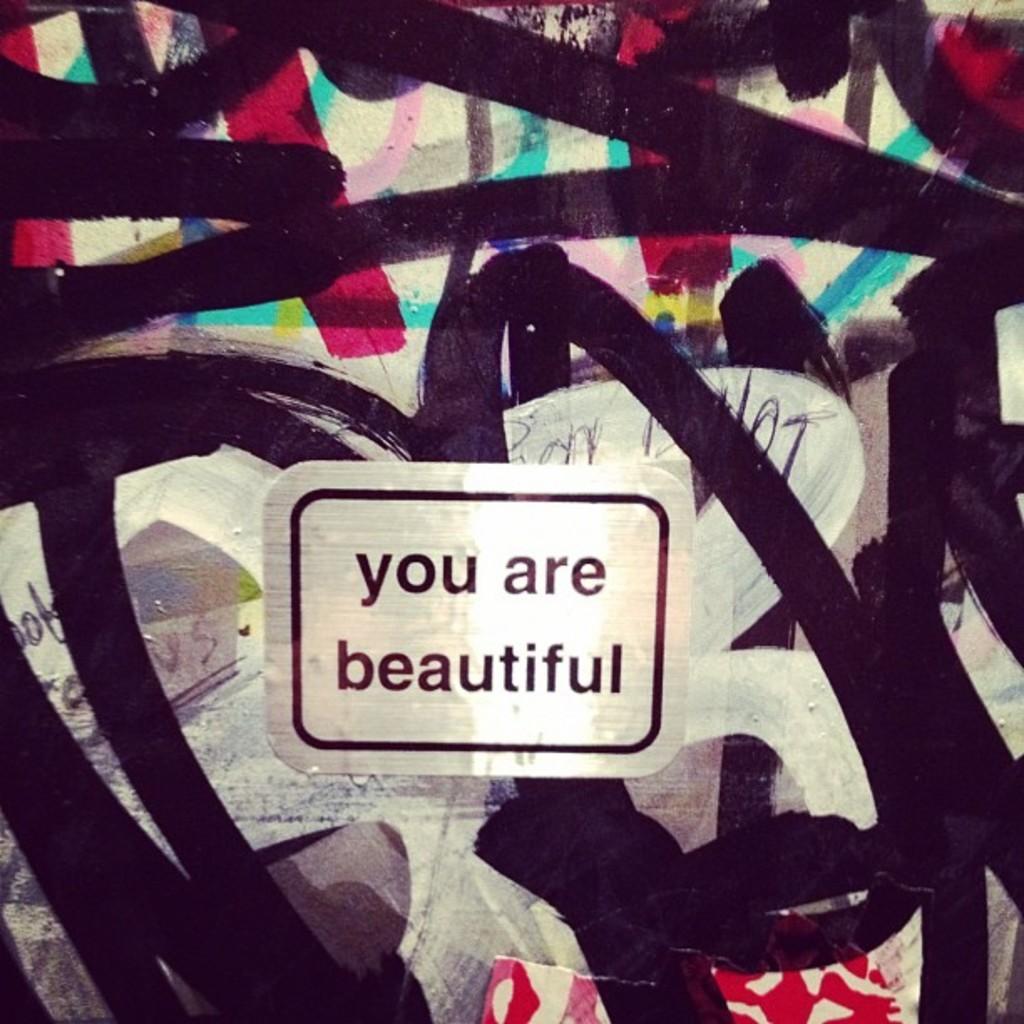In one or two sentences, can you explain what this image depicts? In this picture there is a painting in the center of the image and there is a label on which, it is written as ''you are beautiful.'' 